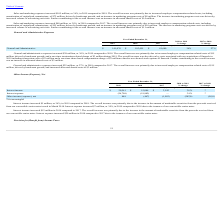According to Zendesk's financial document, What is the percentage increase in General and Administrative expenses from 2018 to 2019 According to the financial document, 36%. The relevant text states: "al and Administrative $ 141,076 $ 103,491 $ 81,680 36% 27%..." Also, What was the increase in general and administrative expenses from 2017 to 2018? According to the financial document, 22 (in millions). The relevant text states: "General and administrative expenses increased $22 million, or 27%, in 2018 compared to 2017. The overall increase was primarily due to increased empl..." Also, can you calculate: What is the difference between the increase in general and administrative expenses from 2018 to 2019 and 2017 to 2018? Based on the calculation: 38 - 22 , the result is 16 (in millions). This is based on the information: "and marketing expenses increased $80 million, or 38%, in 2018 compared to 2017. The overall increase was primarily due to increased employee compensati General and administrative expenses increased $2..." The key data points involved are: 22, 38. Also, What are the components of the costs associated with acquisition of Smooch in 2019? The overall increase was also driven by costs associated with our acquisition of Smooch in 2019 including transaction costs of $3 million and a one-time share-based compensation charge of $3 million related to accelerated stock options of Smooch.. The document states: "mination-related charge of $3 million during 2019. The overall increase was also driven by costs associated with our acquisition of Smooch in 2019 inc..." Also, can you calculate: What is the increase in percentage of general and administrative expenses from 2017 to 2019? To answer this question, I need to perform calculations using the financial data. The calculation is: (141,076 - 81,680)/81,680 , which equals 72.72 (percentage). This is based on the information: "General and Administrative $ 141,076 $ 103,491 $ 81,680 36% 27% General and Administrative $ 141,076 $ 103,491 $ 81,680 36% 27%..." The key data points involved are: 141,076, 81,680. Also, can you calculate: What is the overall increase in general and administrative expenses from 2017 to 2019? Based on the calculation: 38 + 22 , the result is 60 (in millions). This is based on the information: "and marketing expenses increased $80 million, or 38%, in 2018 compared to 2017. The overall increase was primarily due to increased employee compensati General and administrative expenses increased $2..." The key data points involved are: 22, 38. 